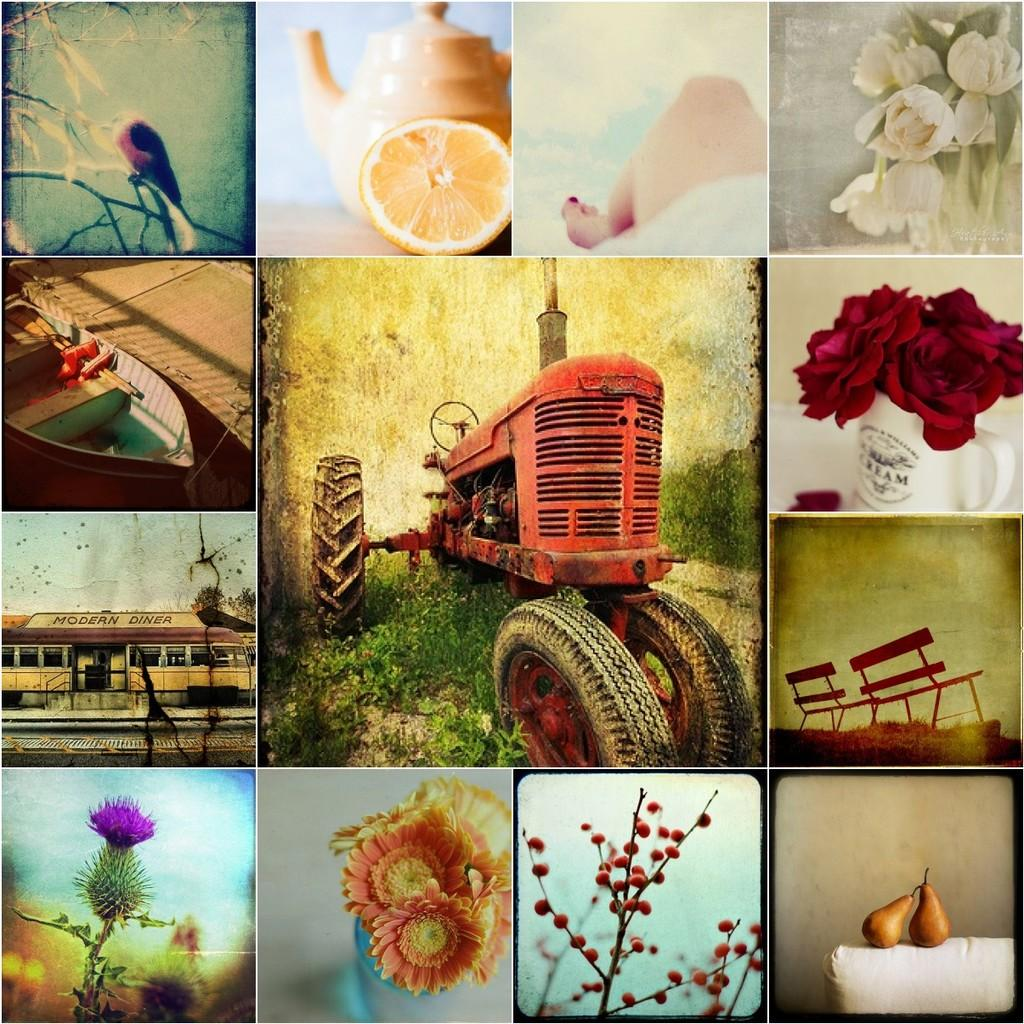What type of vehicle is in the image? There is a vehicle in the image, but the specific type is not mentioned. What is the second mode of transportation in the image? There is a boat in the image. What household item is present in the image? There is a teapot in the image. What type of structure is in the image? There is a building in the image. What type of plant is in the image? There are flowers in the image. What type of outdoor furniture is in the image? There are benches in the image. What decision was made by the flowers in the image? There is no indication in the image that the flowers made any decisions. What type of operation is being performed on the vehicle in the image? There is no operation being performed on the vehicle in the image. 